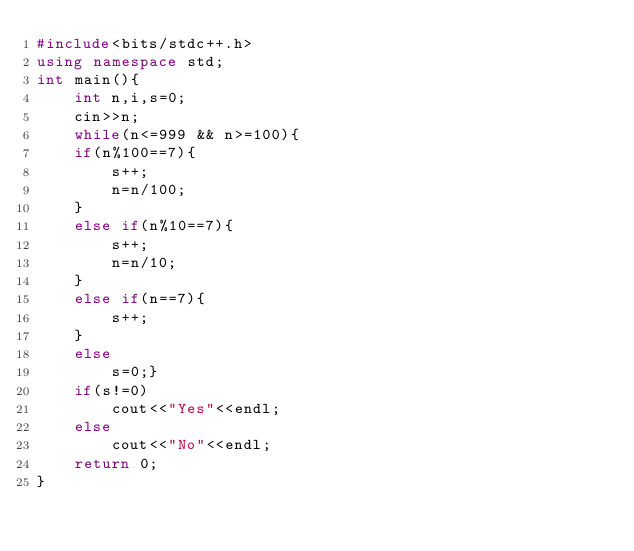<code> <loc_0><loc_0><loc_500><loc_500><_C++_>#include<bits/stdc++.h>
using namespace std;
int main(){
    int n,i,s=0;
    cin>>n;
    while(n<=999 && n>=100){
    if(n%100==7){
        s++;
        n=n/100;
    }
    else if(n%10==7){
        s++;
        n=n/10;
    }
    else if(n==7){
        s++;
    }
    else
        s=0;}
    if(s!=0)
        cout<<"Yes"<<endl;
    else
        cout<<"No"<<endl;
    return 0;
}
</code> 